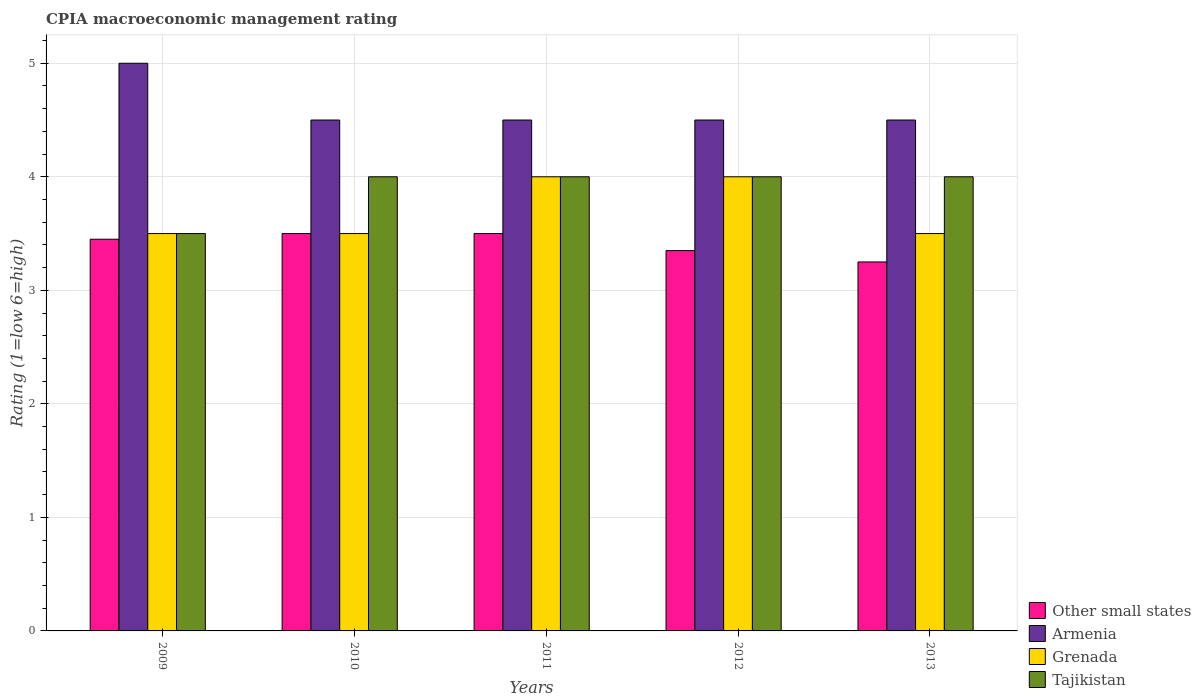How many different coloured bars are there?
Keep it short and to the point. 4. Are the number of bars per tick equal to the number of legend labels?
Keep it short and to the point. Yes. In how many cases, is the number of bars for a given year not equal to the number of legend labels?
Your response must be concise. 0. Across all years, what is the minimum CPIA rating in Armenia?
Provide a succinct answer. 4.5. In which year was the CPIA rating in Grenada maximum?
Your response must be concise. 2011. What is the total CPIA rating in Tajikistan in the graph?
Offer a terse response. 19.5. What is the difference between the CPIA rating in Armenia in 2009 and the CPIA rating in Other small states in 2012?
Offer a terse response. 1.65. What is the average CPIA rating in Grenada per year?
Ensure brevity in your answer.  3.7. In how many years, is the CPIA rating in Tajikistan greater than 2?
Offer a terse response. 5. What is the difference between the highest and the lowest CPIA rating in Tajikistan?
Your response must be concise. 0.5. In how many years, is the CPIA rating in Armenia greater than the average CPIA rating in Armenia taken over all years?
Keep it short and to the point. 1. Is it the case that in every year, the sum of the CPIA rating in Tajikistan and CPIA rating in Other small states is greater than the sum of CPIA rating in Grenada and CPIA rating in Armenia?
Your answer should be compact. No. What does the 2nd bar from the left in 2013 represents?
Provide a short and direct response. Armenia. What does the 3rd bar from the right in 2012 represents?
Provide a short and direct response. Armenia. Are all the bars in the graph horizontal?
Your answer should be compact. No. How many years are there in the graph?
Provide a short and direct response. 5. What is the difference between two consecutive major ticks on the Y-axis?
Offer a very short reply. 1. Are the values on the major ticks of Y-axis written in scientific E-notation?
Make the answer very short. No. Does the graph contain grids?
Provide a short and direct response. Yes. How many legend labels are there?
Keep it short and to the point. 4. How are the legend labels stacked?
Your answer should be compact. Vertical. What is the title of the graph?
Provide a short and direct response. CPIA macroeconomic management rating. What is the Rating (1=low 6=high) of Other small states in 2009?
Provide a short and direct response. 3.45. What is the Rating (1=low 6=high) in Armenia in 2009?
Give a very brief answer. 5. What is the Rating (1=low 6=high) of Other small states in 2010?
Provide a succinct answer. 3.5. What is the Rating (1=low 6=high) of Armenia in 2010?
Offer a very short reply. 4.5. What is the Rating (1=low 6=high) of Armenia in 2011?
Make the answer very short. 4.5. What is the Rating (1=low 6=high) of Grenada in 2011?
Ensure brevity in your answer.  4. What is the Rating (1=low 6=high) of Other small states in 2012?
Ensure brevity in your answer.  3.35. What is the Rating (1=low 6=high) in Armenia in 2012?
Make the answer very short. 4.5. What is the Rating (1=low 6=high) in Grenada in 2012?
Your answer should be compact. 4. What is the Rating (1=low 6=high) in Other small states in 2013?
Keep it short and to the point. 3.25. Across all years, what is the maximum Rating (1=low 6=high) in Armenia?
Your response must be concise. 5. Across all years, what is the maximum Rating (1=low 6=high) in Grenada?
Keep it short and to the point. 4. Across all years, what is the maximum Rating (1=low 6=high) in Tajikistan?
Your answer should be very brief. 4. What is the total Rating (1=low 6=high) of Other small states in the graph?
Your answer should be compact. 17.05. What is the total Rating (1=low 6=high) in Armenia in the graph?
Ensure brevity in your answer.  23. What is the total Rating (1=low 6=high) in Grenada in the graph?
Provide a short and direct response. 18.5. What is the difference between the Rating (1=low 6=high) of Armenia in 2009 and that in 2010?
Your response must be concise. 0.5. What is the difference between the Rating (1=low 6=high) of Grenada in 2009 and that in 2010?
Your response must be concise. 0. What is the difference between the Rating (1=low 6=high) of Tajikistan in 2009 and that in 2010?
Keep it short and to the point. -0.5. What is the difference between the Rating (1=low 6=high) in Other small states in 2009 and that in 2011?
Ensure brevity in your answer.  -0.05. What is the difference between the Rating (1=low 6=high) of Grenada in 2009 and that in 2011?
Ensure brevity in your answer.  -0.5. What is the difference between the Rating (1=low 6=high) in Tajikistan in 2009 and that in 2011?
Your answer should be compact. -0.5. What is the difference between the Rating (1=low 6=high) in Other small states in 2009 and that in 2012?
Your answer should be very brief. 0.1. What is the difference between the Rating (1=low 6=high) in Tajikistan in 2009 and that in 2012?
Provide a short and direct response. -0.5. What is the difference between the Rating (1=low 6=high) in Tajikistan in 2009 and that in 2013?
Keep it short and to the point. -0.5. What is the difference between the Rating (1=low 6=high) of Other small states in 2010 and that in 2011?
Your answer should be very brief. 0. What is the difference between the Rating (1=low 6=high) in Grenada in 2010 and that in 2011?
Make the answer very short. -0.5. What is the difference between the Rating (1=low 6=high) of Other small states in 2010 and that in 2012?
Make the answer very short. 0.15. What is the difference between the Rating (1=low 6=high) in Other small states in 2010 and that in 2013?
Make the answer very short. 0.25. What is the difference between the Rating (1=low 6=high) in Grenada in 2010 and that in 2013?
Make the answer very short. 0. What is the difference between the Rating (1=low 6=high) in Other small states in 2011 and that in 2012?
Give a very brief answer. 0.15. What is the difference between the Rating (1=low 6=high) of Grenada in 2011 and that in 2012?
Ensure brevity in your answer.  0. What is the difference between the Rating (1=low 6=high) in Tajikistan in 2011 and that in 2012?
Offer a very short reply. 0. What is the difference between the Rating (1=low 6=high) of Other small states in 2011 and that in 2013?
Make the answer very short. 0.25. What is the difference between the Rating (1=low 6=high) of Armenia in 2011 and that in 2013?
Your response must be concise. 0. What is the difference between the Rating (1=low 6=high) in Grenada in 2011 and that in 2013?
Your response must be concise. 0.5. What is the difference between the Rating (1=low 6=high) of Tajikistan in 2011 and that in 2013?
Your answer should be compact. 0. What is the difference between the Rating (1=low 6=high) of Armenia in 2012 and that in 2013?
Provide a short and direct response. 0. What is the difference between the Rating (1=low 6=high) in Grenada in 2012 and that in 2013?
Keep it short and to the point. 0.5. What is the difference between the Rating (1=low 6=high) of Tajikistan in 2012 and that in 2013?
Provide a short and direct response. 0. What is the difference between the Rating (1=low 6=high) of Other small states in 2009 and the Rating (1=low 6=high) of Armenia in 2010?
Give a very brief answer. -1.05. What is the difference between the Rating (1=low 6=high) of Other small states in 2009 and the Rating (1=low 6=high) of Grenada in 2010?
Ensure brevity in your answer.  -0.05. What is the difference between the Rating (1=low 6=high) in Other small states in 2009 and the Rating (1=low 6=high) in Tajikistan in 2010?
Make the answer very short. -0.55. What is the difference between the Rating (1=low 6=high) in Grenada in 2009 and the Rating (1=low 6=high) in Tajikistan in 2010?
Offer a terse response. -0.5. What is the difference between the Rating (1=low 6=high) of Other small states in 2009 and the Rating (1=low 6=high) of Armenia in 2011?
Provide a short and direct response. -1.05. What is the difference between the Rating (1=low 6=high) in Other small states in 2009 and the Rating (1=low 6=high) in Grenada in 2011?
Your answer should be compact. -0.55. What is the difference between the Rating (1=low 6=high) of Other small states in 2009 and the Rating (1=low 6=high) of Tajikistan in 2011?
Your response must be concise. -0.55. What is the difference between the Rating (1=low 6=high) in Grenada in 2009 and the Rating (1=low 6=high) in Tajikistan in 2011?
Offer a terse response. -0.5. What is the difference between the Rating (1=low 6=high) in Other small states in 2009 and the Rating (1=low 6=high) in Armenia in 2012?
Your answer should be compact. -1.05. What is the difference between the Rating (1=low 6=high) of Other small states in 2009 and the Rating (1=low 6=high) of Grenada in 2012?
Make the answer very short. -0.55. What is the difference between the Rating (1=low 6=high) of Other small states in 2009 and the Rating (1=low 6=high) of Tajikistan in 2012?
Make the answer very short. -0.55. What is the difference between the Rating (1=low 6=high) of Armenia in 2009 and the Rating (1=low 6=high) of Grenada in 2012?
Keep it short and to the point. 1. What is the difference between the Rating (1=low 6=high) of Armenia in 2009 and the Rating (1=low 6=high) of Tajikistan in 2012?
Keep it short and to the point. 1. What is the difference between the Rating (1=low 6=high) of Grenada in 2009 and the Rating (1=low 6=high) of Tajikistan in 2012?
Make the answer very short. -0.5. What is the difference between the Rating (1=low 6=high) in Other small states in 2009 and the Rating (1=low 6=high) in Armenia in 2013?
Offer a terse response. -1.05. What is the difference between the Rating (1=low 6=high) in Other small states in 2009 and the Rating (1=low 6=high) in Tajikistan in 2013?
Provide a short and direct response. -0.55. What is the difference between the Rating (1=low 6=high) of Armenia in 2009 and the Rating (1=low 6=high) of Grenada in 2013?
Offer a terse response. 1.5. What is the difference between the Rating (1=low 6=high) in Armenia in 2009 and the Rating (1=low 6=high) in Tajikistan in 2013?
Your answer should be very brief. 1. What is the difference between the Rating (1=low 6=high) of Grenada in 2009 and the Rating (1=low 6=high) of Tajikistan in 2013?
Offer a very short reply. -0.5. What is the difference between the Rating (1=low 6=high) of Other small states in 2010 and the Rating (1=low 6=high) of Grenada in 2011?
Offer a very short reply. -0.5. What is the difference between the Rating (1=low 6=high) of Other small states in 2010 and the Rating (1=low 6=high) of Tajikistan in 2011?
Your response must be concise. -0.5. What is the difference between the Rating (1=low 6=high) in Armenia in 2010 and the Rating (1=low 6=high) in Grenada in 2011?
Your answer should be compact. 0.5. What is the difference between the Rating (1=low 6=high) in Other small states in 2010 and the Rating (1=low 6=high) in Grenada in 2012?
Your response must be concise. -0.5. What is the difference between the Rating (1=low 6=high) of Other small states in 2010 and the Rating (1=low 6=high) of Tajikistan in 2012?
Provide a short and direct response. -0.5. What is the difference between the Rating (1=low 6=high) of Armenia in 2010 and the Rating (1=low 6=high) of Tajikistan in 2012?
Keep it short and to the point. 0.5. What is the difference between the Rating (1=low 6=high) in Grenada in 2010 and the Rating (1=low 6=high) in Tajikistan in 2012?
Offer a terse response. -0.5. What is the difference between the Rating (1=low 6=high) of Grenada in 2010 and the Rating (1=low 6=high) of Tajikistan in 2013?
Offer a terse response. -0.5. What is the difference between the Rating (1=low 6=high) of Other small states in 2011 and the Rating (1=low 6=high) of Armenia in 2012?
Offer a terse response. -1. What is the difference between the Rating (1=low 6=high) of Other small states in 2011 and the Rating (1=low 6=high) of Grenada in 2012?
Provide a short and direct response. -0.5. What is the difference between the Rating (1=low 6=high) of Other small states in 2011 and the Rating (1=low 6=high) of Tajikistan in 2012?
Make the answer very short. -0.5. What is the difference between the Rating (1=low 6=high) of Armenia in 2011 and the Rating (1=low 6=high) of Grenada in 2012?
Offer a terse response. 0.5. What is the difference between the Rating (1=low 6=high) in Armenia in 2011 and the Rating (1=low 6=high) in Tajikistan in 2012?
Offer a terse response. 0.5. What is the difference between the Rating (1=low 6=high) in Other small states in 2011 and the Rating (1=low 6=high) in Grenada in 2013?
Provide a short and direct response. 0. What is the difference between the Rating (1=low 6=high) in Other small states in 2011 and the Rating (1=low 6=high) in Tajikistan in 2013?
Offer a very short reply. -0.5. What is the difference between the Rating (1=low 6=high) of Armenia in 2011 and the Rating (1=low 6=high) of Tajikistan in 2013?
Ensure brevity in your answer.  0.5. What is the difference between the Rating (1=low 6=high) in Grenada in 2011 and the Rating (1=low 6=high) in Tajikistan in 2013?
Offer a very short reply. 0. What is the difference between the Rating (1=low 6=high) in Other small states in 2012 and the Rating (1=low 6=high) in Armenia in 2013?
Offer a very short reply. -1.15. What is the difference between the Rating (1=low 6=high) in Other small states in 2012 and the Rating (1=low 6=high) in Tajikistan in 2013?
Ensure brevity in your answer.  -0.65. What is the difference between the Rating (1=low 6=high) in Armenia in 2012 and the Rating (1=low 6=high) in Grenada in 2013?
Provide a succinct answer. 1. What is the difference between the Rating (1=low 6=high) in Armenia in 2012 and the Rating (1=low 6=high) in Tajikistan in 2013?
Keep it short and to the point. 0.5. What is the average Rating (1=low 6=high) of Other small states per year?
Give a very brief answer. 3.41. What is the average Rating (1=low 6=high) of Armenia per year?
Offer a very short reply. 4.6. What is the average Rating (1=low 6=high) in Grenada per year?
Provide a succinct answer. 3.7. What is the average Rating (1=low 6=high) in Tajikistan per year?
Offer a terse response. 3.9. In the year 2009, what is the difference between the Rating (1=low 6=high) in Other small states and Rating (1=low 6=high) in Armenia?
Your answer should be very brief. -1.55. In the year 2009, what is the difference between the Rating (1=low 6=high) of Other small states and Rating (1=low 6=high) of Grenada?
Your response must be concise. -0.05. In the year 2009, what is the difference between the Rating (1=low 6=high) in Other small states and Rating (1=low 6=high) in Tajikistan?
Make the answer very short. -0.05. In the year 2009, what is the difference between the Rating (1=low 6=high) in Armenia and Rating (1=low 6=high) in Grenada?
Provide a short and direct response. 1.5. In the year 2010, what is the difference between the Rating (1=low 6=high) in Other small states and Rating (1=low 6=high) in Grenada?
Offer a very short reply. 0. In the year 2010, what is the difference between the Rating (1=low 6=high) of Other small states and Rating (1=low 6=high) of Tajikistan?
Provide a succinct answer. -0.5. In the year 2010, what is the difference between the Rating (1=low 6=high) in Armenia and Rating (1=low 6=high) in Tajikistan?
Give a very brief answer. 0.5. In the year 2010, what is the difference between the Rating (1=low 6=high) of Grenada and Rating (1=low 6=high) of Tajikistan?
Offer a terse response. -0.5. In the year 2011, what is the difference between the Rating (1=low 6=high) in Other small states and Rating (1=low 6=high) in Tajikistan?
Provide a short and direct response. -0.5. In the year 2011, what is the difference between the Rating (1=low 6=high) in Armenia and Rating (1=low 6=high) in Grenada?
Your answer should be compact. 0.5. In the year 2011, what is the difference between the Rating (1=low 6=high) of Armenia and Rating (1=low 6=high) of Tajikistan?
Keep it short and to the point. 0.5. In the year 2011, what is the difference between the Rating (1=low 6=high) of Grenada and Rating (1=low 6=high) of Tajikistan?
Make the answer very short. 0. In the year 2012, what is the difference between the Rating (1=low 6=high) of Other small states and Rating (1=low 6=high) of Armenia?
Offer a very short reply. -1.15. In the year 2012, what is the difference between the Rating (1=low 6=high) of Other small states and Rating (1=low 6=high) of Grenada?
Your answer should be very brief. -0.65. In the year 2012, what is the difference between the Rating (1=low 6=high) of Other small states and Rating (1=low 6=high) of Tajikistan?
Your response must be concise. -0.65. In the year 2012, what is the difference between the Rating (1=low 6=high) of Armenia and Rating (1=low 6=high) of Grenada?
Provide a succinct answer. 0.5. In the year 2012, what is the difference between the Rating (1=low 6=high) of Armenia and Rating (1=low 6=high) of Tajikistan?
Ensure brevity in your answer.  0.5. In the year 2013, what is the difference between the Rating (1=low 6=high) in Other small states and Rating (1=low 6=high) in Armenia?
Your response must be concise. -1.25. In the year 2013, what is the difference between the Rating (1=low 6=high) of Other small states and Rating (1=low 6=high) of Grenada?
Keep it short and to the point. -0.25. In the year 2013, what is the difference between the Rating (1=low 6=high) of Other small states and Rating (1=low 6=high) of Tajikistan?
Make the answer very short. -0.75. What is the ratio of the Rating (1=low 6=high) in Other small states in 2009 to that in 2010?
Your answer should be compact. 0.99. What is the ratio of the Rating (1=low 6=high) of Armenia in 2009 to that in 2010?
Provide a short and direct response. 1.11. What is the ratio of the Rating (1=low 6=high) of Other small states in 2009 to that in 2011?
Provide a short and direct response. 0.99. What is the ratio of the Rating (1=low 6=high) in Armenia in 2009 to that in 2011?
Keep it short and to the point. 1.11. What is the ratio of the Rating (1=low 6=high) in Grenada in 2009 to that in 2011?
Provide a short and direct response. 0.88. What is the ratio of the Rating (1=low 6=high) in Tajikistan in 2009 to that in 2011?
Provide a succinct answer. 0.88. What is the ratio of the Rating (1=low 6=high) in Other small states in 2009 to that in 2012?
Make the answer very short. 1.03. What is the ratio of the Rating (1=low 6=high) of Armenia in 2009 to that in 2012?
Offer a terse response. 1.11. What is the ratio of the Rating (1=low 6=high) of Other small states in 2009 to that in 2013?
Your response must be concise. 1.06. What is the ratio of the Rating (1=low 6=high) in Armenia in 2009 to that in 2013?
Provide a succinct answer. 1.11. What is the ratio of the Rating (1=low 6=high) of Other small states in 2010 to that in 2011?
Ensure brevity in your answer.  1. What is the ratio of the Rating (1=low 6=high) of Grenada in 2010 to that in 2011?
Provide a short and direct response. 0.88. What is the ratio of the Rating (1=low 6=high) in Other small states in 2010 to that in 2012?
Ensure brevity in your answer.  1.04. What is the ratio of the Rating (1=low 6=high) in Grenada in 2010 to that in 2012?
Your response must be concise. 0.88. What is the ratio of the Rating (1=low 6=high) of Tajikistan in 2010 to that in 2012?
Give a very brief answer. 1. What is the ratio of the Rating (1=low 6=high) of Other small states in 2010 to that in 2013?
Provide a short and direct response. 1.08. What is the ratio of the Rating (1=low 6=high) in Grenada in 2010 to that in 2013?
Ensure brevity in your answer.  1. What is the ratio of the Rating (1=low 6=high) in Tajikistan in 2010 to that in 2013?
Ensure brevity in your answer.  1. What is the ratio of the Rating (1=low 6=high) of Other small states in 2011 to that in 2012?
Your answer should be very brief. 1.04. What is the ratio of the Rating (1=low 6=high) in Grenada in 2011 to that in 2012?
Provide a succinct answer. 1. What is the ratio of the Rating (1=low 6=high) in Tajikistan in 2011 to that in 2013?
Give a very brief answer. 1. What is the ratio of the Rating (1=low 6=high) in Other small states in 2012 to that in 2013?
Ensure brevity in your answer.  1.03. What is the difference between the highest and the lowest Rating (1=low 6=high) of Other small states?
Offer a very short reply. 0.25. What is the difference between the highest and the lowest Rating (1=low 6=high) in Armenia?
Provide a short and direct response. 0.5. What is the difference between the highest and the lowest Rating (1=low 6=high) in Grenada?
Make the answer very short. 0.5. 